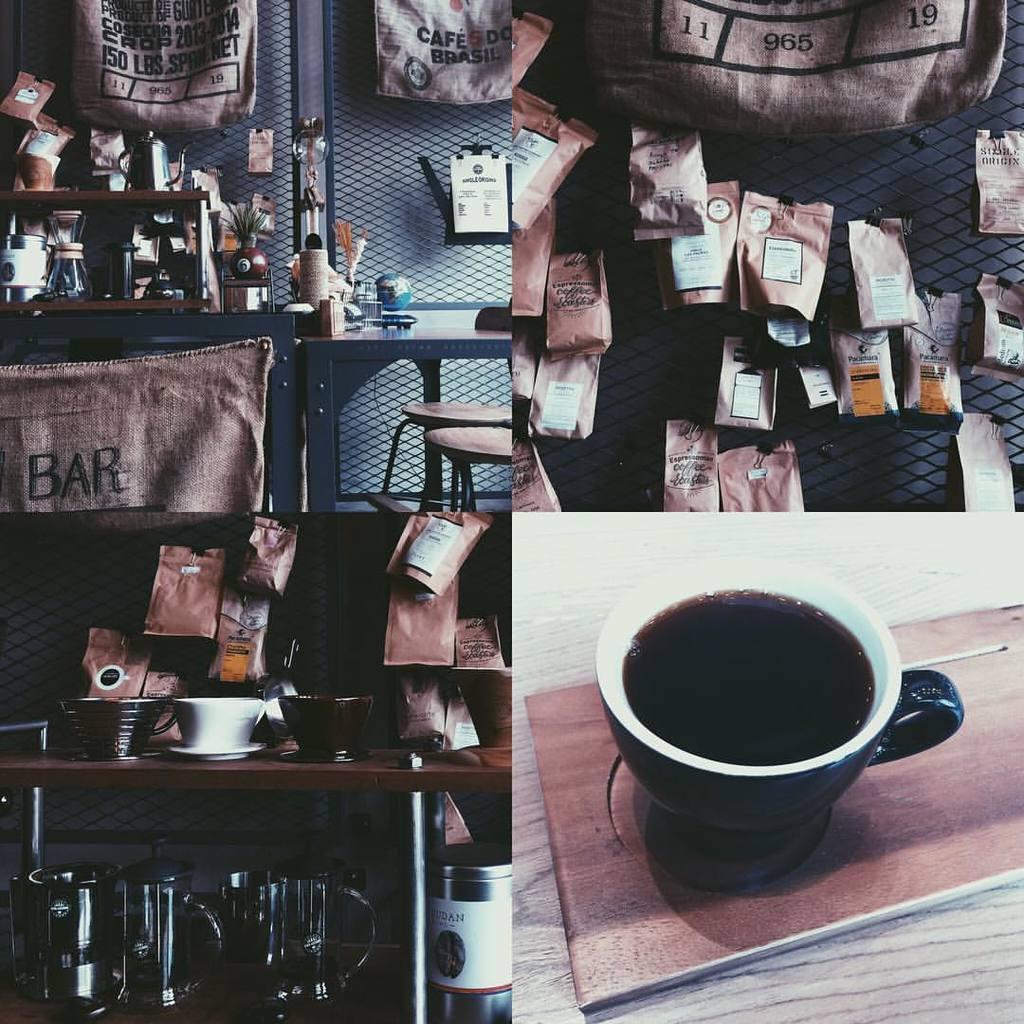Could you give a brief overview of what you see in this image? In this image we can see at the bottom right there is a cup of coffee and the top right there are some kind of packets hanging and at the top left we can see a table here a chair at the bottom left we can see cutlery on table totally this image is a collage image 